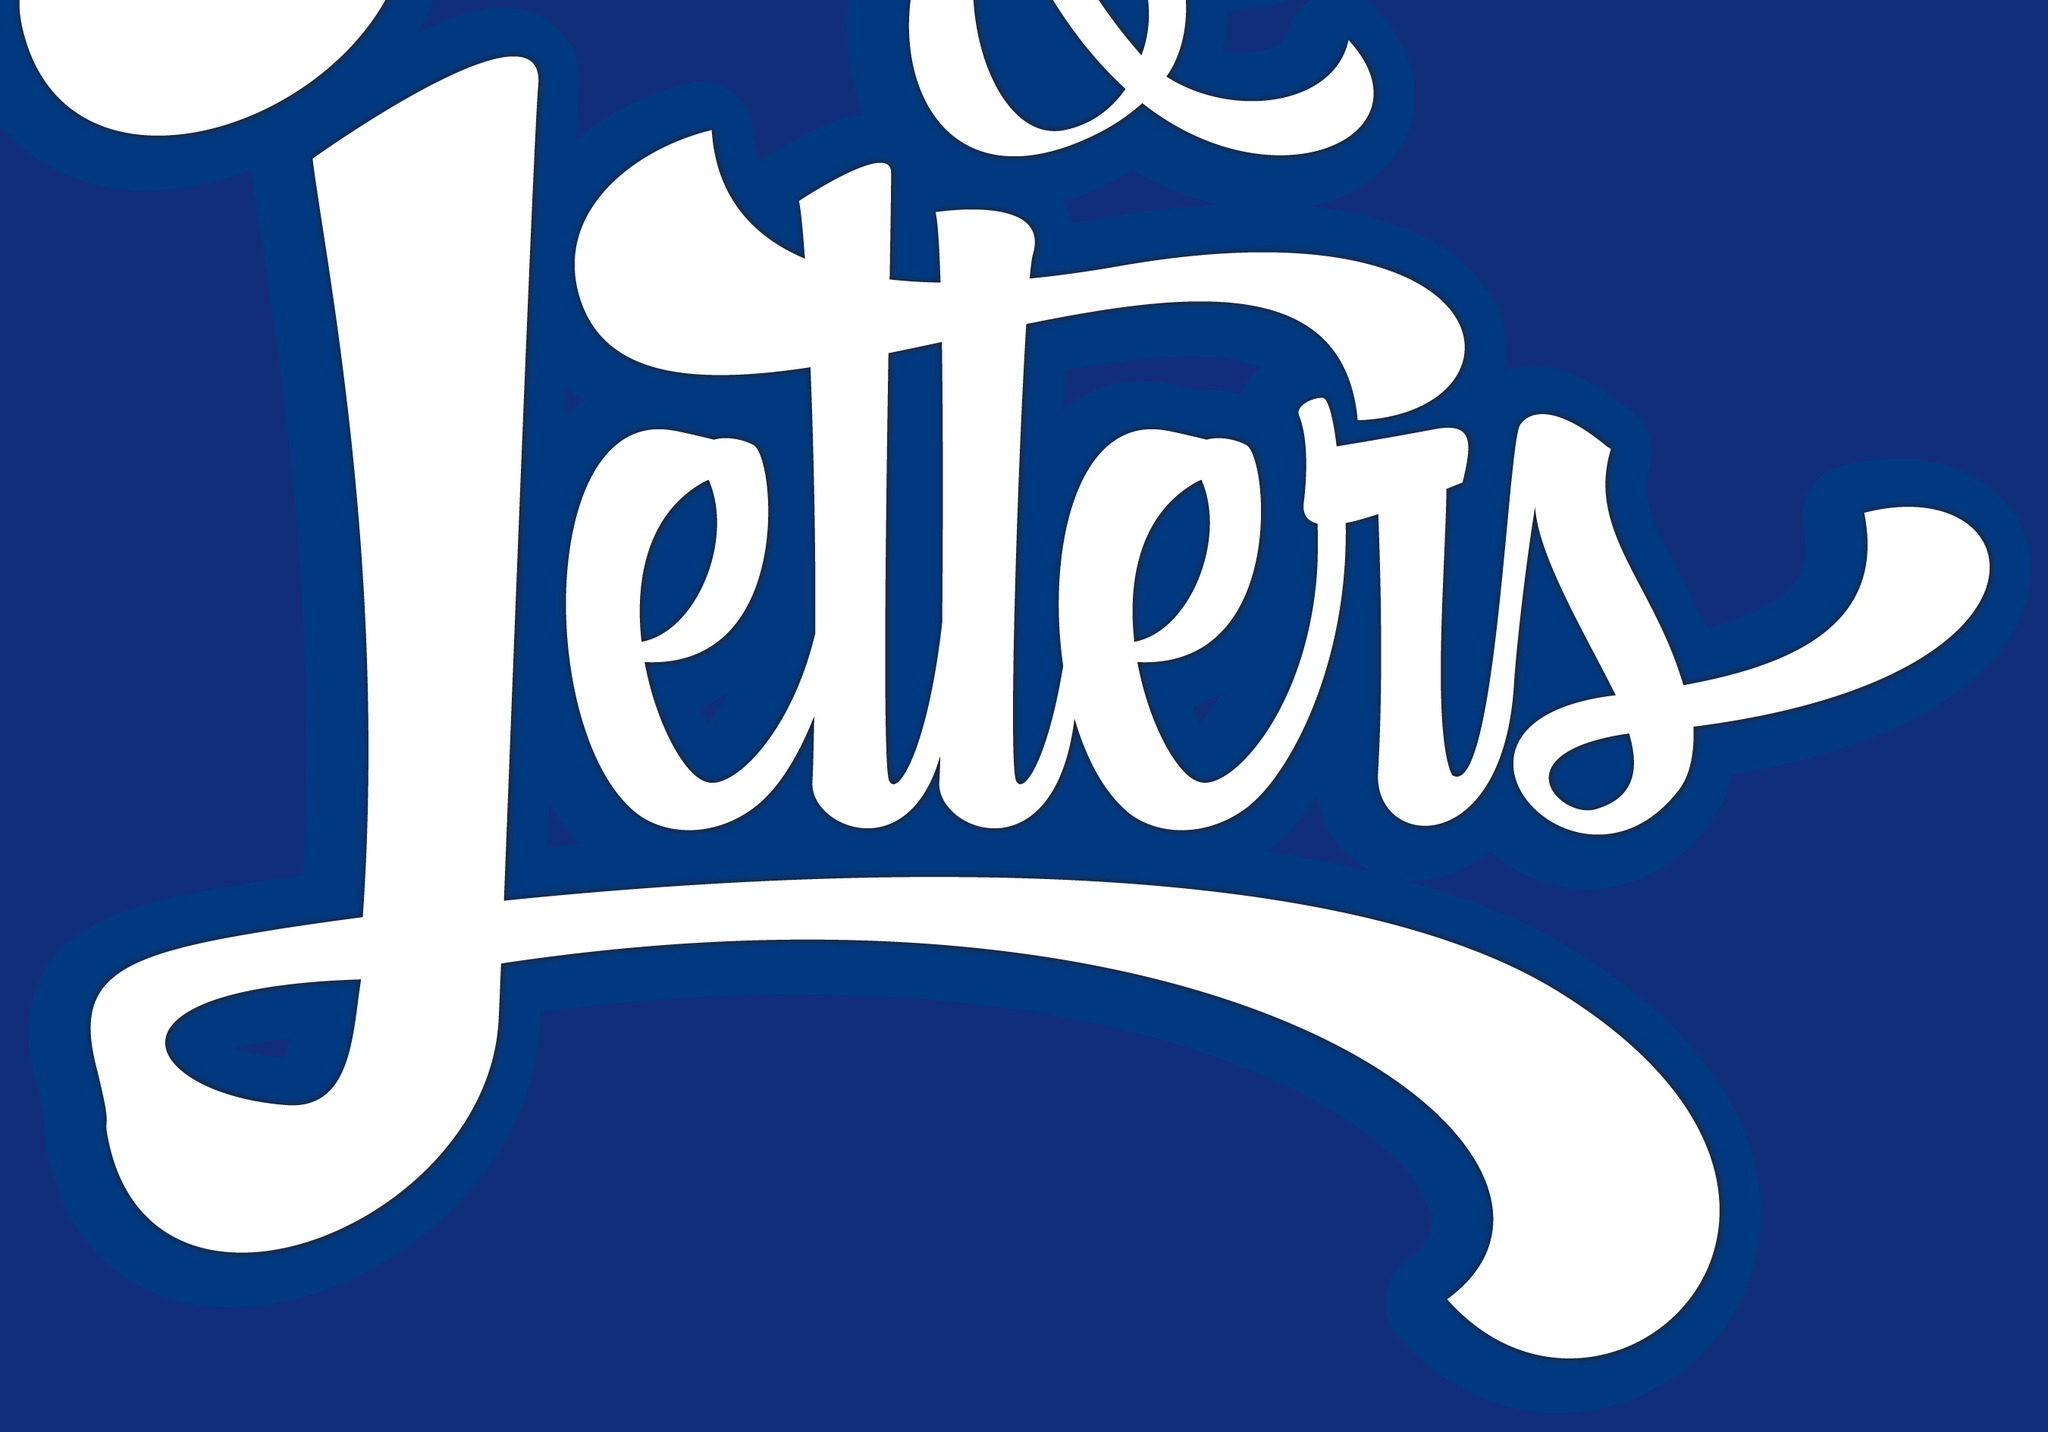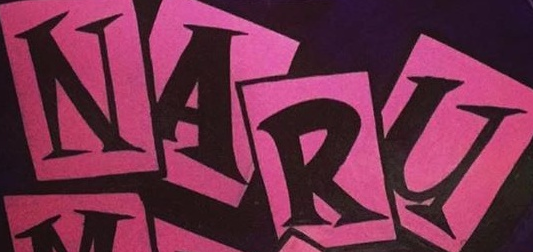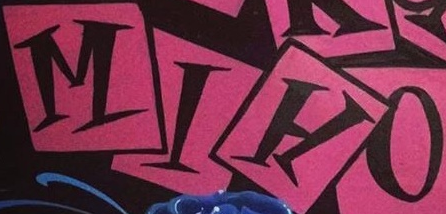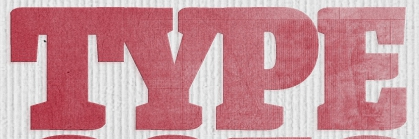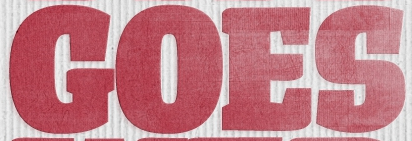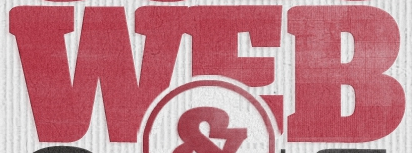Read the text from these images in sequence, separated by a semicolon. Letters; NARU; MIHO; TYPE; GOES; WEB 